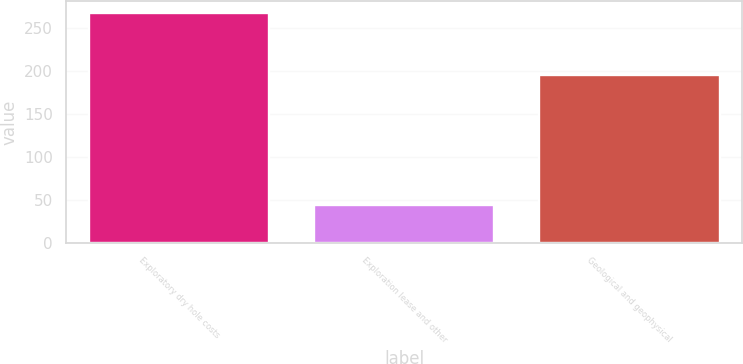Convert chart to OTSL. <chart><loc_0><loc_0><loc_500><loc_500><bar_chart><fcel>Exploratory dry hole costs<fcel>Exploration lease and other<fcel>Geological and geophysical<nl><fcel>268<fcel>44<fcel>195<nl></chart> 